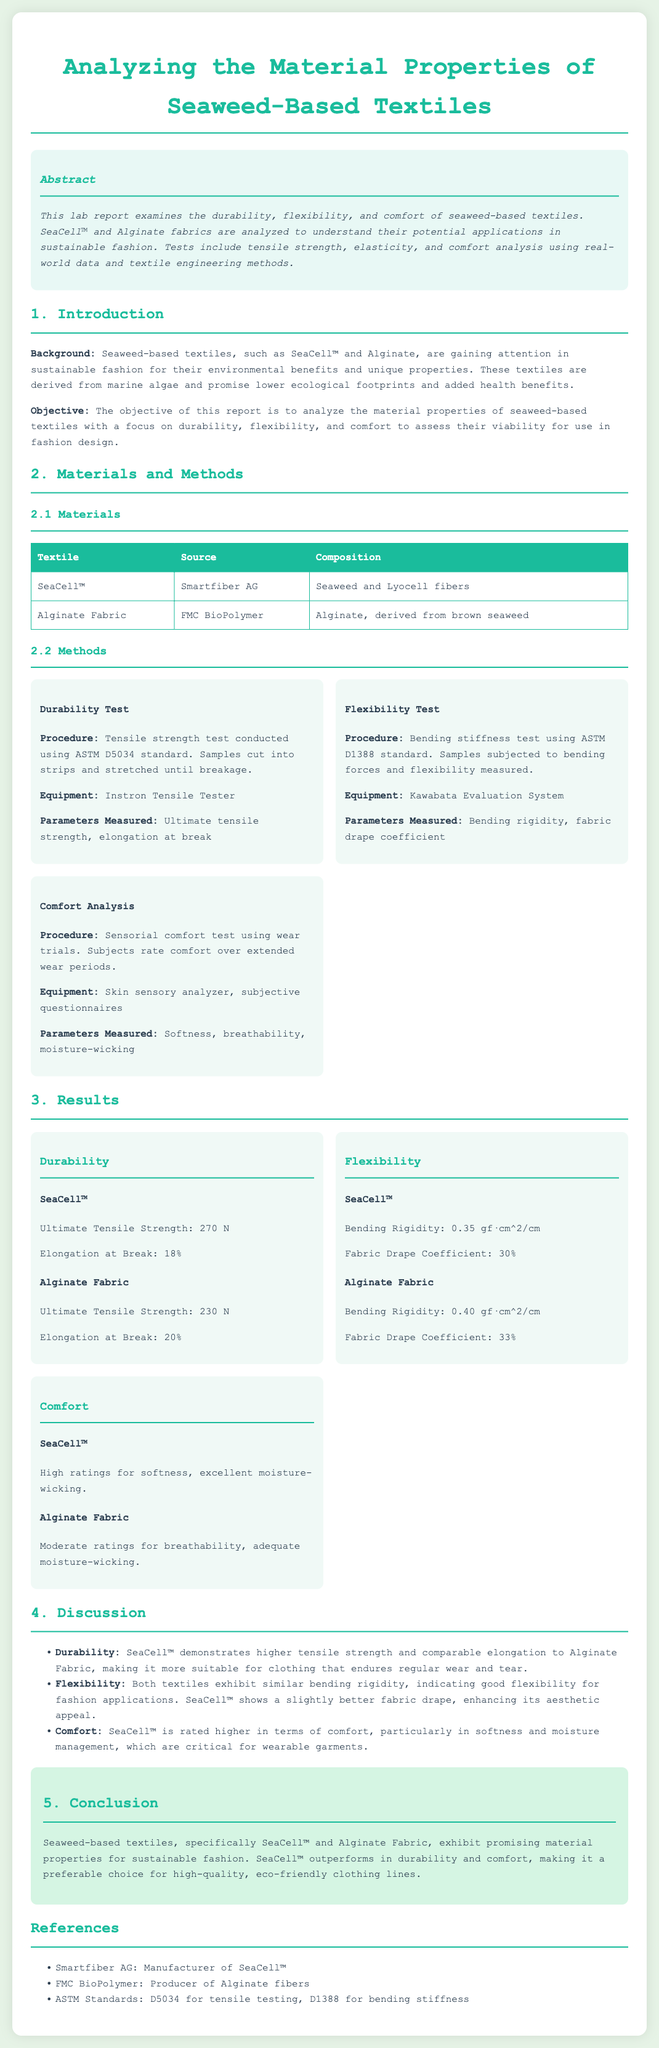What are the two types of seaweed-based textiles analyzed? The document lists SeaCell™ and Alginate Fabric as the two textiles under analysis.
Answer: SeaCell™ and Alginate Fabric What is the tensile strength of SeaCell™? The report provides specific results for SeaCell™, which show its ultimate tensile strength to be 270 N.
Answer: 270 N What procedure is used in the durability test? The durability test procedure follows the ASTM D5034 standard for tensile strength testing.
Answer: ASTM D5034 Which fabric received higher ratings for comfort? Comfort analysis results indicate that SeaCell™ received higher ratings for softness and moisture management compared to Alginate Fabric.
Answer: SeaCell™ What does a lower bending rigidity indicate? A lower bending rigidity suggests better flexibility, which is relevant for evaluating the suitability of fabrics for fashion applications.
Answer: Better flexibility What is the elongation at break for Alginate Fabric? The document specifies that Alginate Fabric has an elongation at break of 20%.
Answer: 20% What equipment was used for flexibility testing? The Kawabata Evaluation System is mentioned as the equipment used for measuring flexibility.
Answer: Kawabata Evaluation System How does SeaCell™ compare to Alginate Fabric regarding softness? The results show that SeaCell™ has high ratings for softness, indicating superior comfort compared to Alginate Fabric.
Answer: Superior comfort 